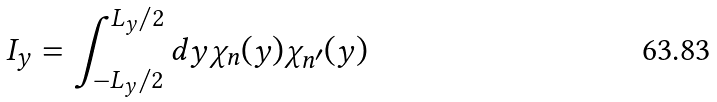<formula> <loc_0><loc_0><loc_500><loc_500>I _ { y } = \int _ { - L _ { y } / 2 } ^ { L _ { y } / 2 } d y \chi _ { n } ( y ) \chi _ { n ^ { \prime } } ( y )</formula> 